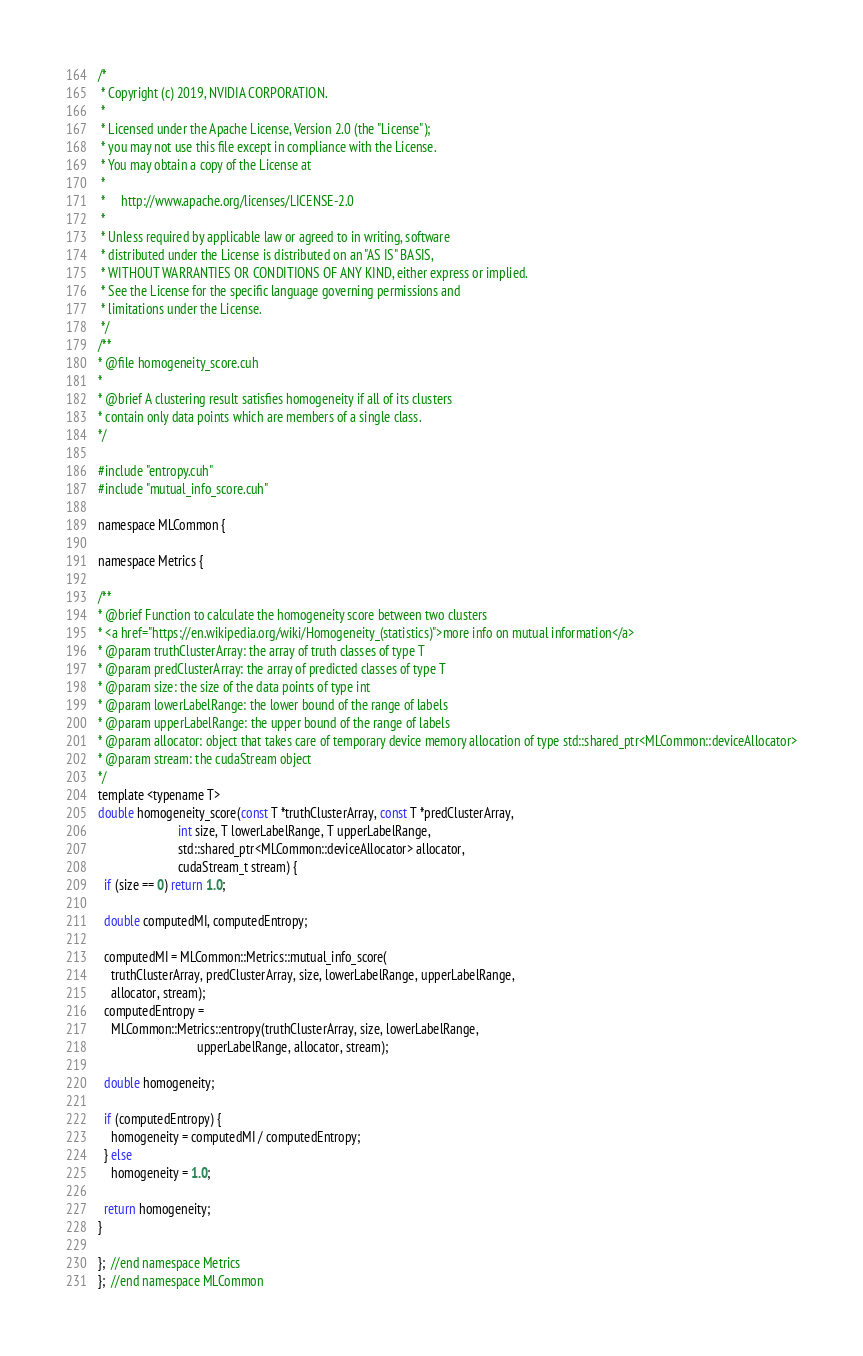Convert code to text. <code><loc_0><loc_0><loc_500><loc_500><_Cuda_>/*
 * Copyright (c) 2019, NVIDIA CORPORATION.
 *
 * Licensed under the Apache License, Version 2.0 (the "License");
 * you may not use this file except in compliance with the License.
 * You may obtain a copy of the License at
 *
 *     http://www.apache.org/licenses/LICENSE-2.0
 *
 * Unless required by applicable law or agreed to in writing, software
 * distributed under the License is distributed on an "AS IS" BASIS,
 * WITHOUT WARRANTIES OR CONDITIONS OF ANY KIND, either express or implied.
 * See the License for the specific language governing permissions and
 * limitations under the License.
 */
/**
* @file homogeneity_score.cuh
*
* @brief A clustering result satisfies homogeneity if all of its clusters
* contain only data points which are members of a single class.
*/

#include "entropy.cuh"
#include "mutual_info_score.cuh"

namespace MLCommon {

namespace Metrics {

/**
* @brief Function to calculate the homogeneity score between two clusters
* <a href="https://en.wikipedia.org/wiki/Homogeneity_(statistics)">more info on mutual information</a>
* @param truthClusterArray: the array of truth classes of type T
* @param predClusterArray: the array of predicted classes of type T
* @param size: the size of the data points of type int
* @param lowerLabelRange: the lower bound of the range of labels
* @param upperLabelRange: the upper bound of the range of labels
* @param allocator: object that takes care of temporary device memory allocation of type std::shared_ptr<MLCommon::deviceAllocator>
* @param stream: the cudaStream object
*/
template <typename T>
double homogeneity_score(const T *truthClusterArray, const T *predClusterArray,
                         int size, T lowerLabelRange, T upperLabelRange,
                         std::shared_ptr<MLCommon::deviceAllocator> allocator,
                         cudaStream_t stream) {
  if (size == 0) return 1.0;

  double computedMI, computedEntropy;

  computedMI = MLCommon::Metrics::mutual_info_score(
    truthClusterArray, predClusterArray, size, lowerLabelRange, upperLabelRange,
    allocator, stream);
  computedEntropy =
    MLCommon::Metrics::entropy(truthClusterArray, size, lowerLabelRange,
                               upperLabelRange, allocator, stream);

  double homogeneity;

  if (computedEntropy) {
    homogeneity = computedMI / computedEntropy;
  } else
    homogeneity = 1.0;

  return homogeneity;
}

};  //end namespace Metrics
};  //end namespace MLCommon
</code> 